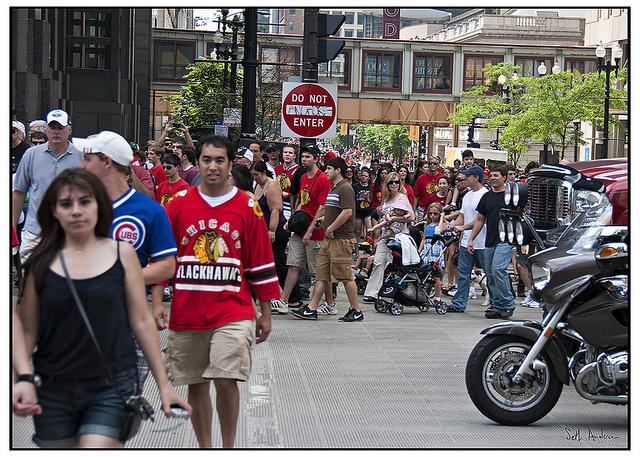Who captains the team of the jersey in red? Please explain your reasoning. jonathan toes. He has captained the team since the 2008-2009 season. 